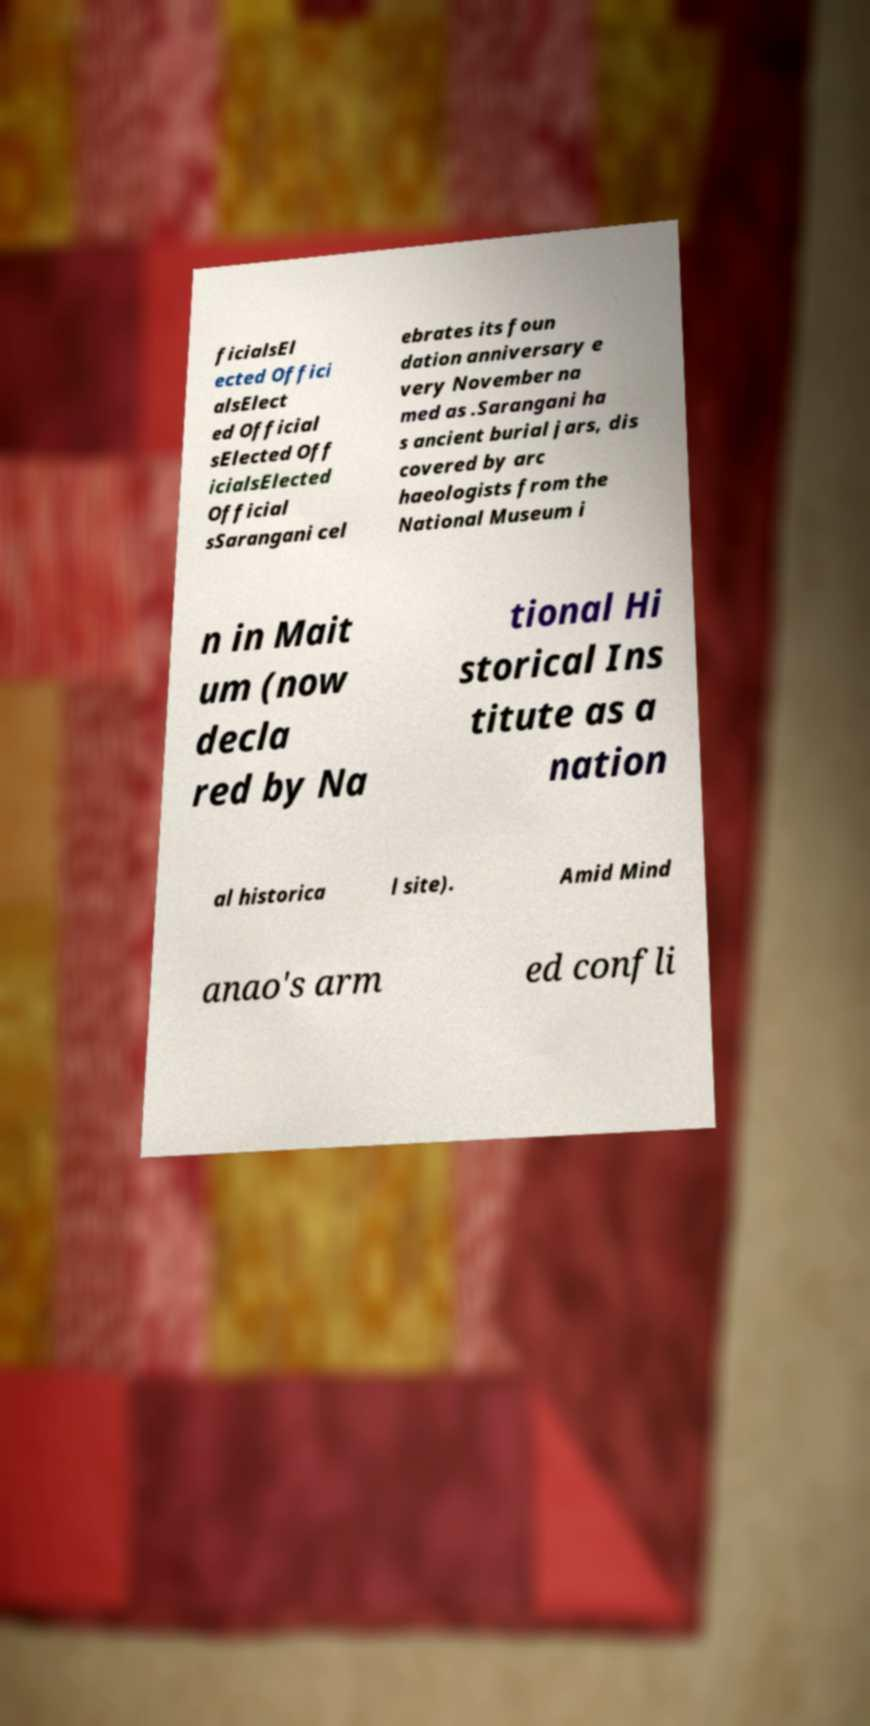Can you read and provide the text displayed in the image?This photo seems to have some interesting text. Can you extract and type it out for me? ficialsEl ected Offici alsElect ed Official sElected Off icialsElected Official sSarangani cel ebrates its foun dation anniversary e very November na med as .Sarangani ha s ancient burial jars, dis covered by arc haeologists from the National Museum i n in Mait um (now decla red by Na tional Hi storical Ins titute as a nation al historica l site). Amid Mind anao's arm ed confli 